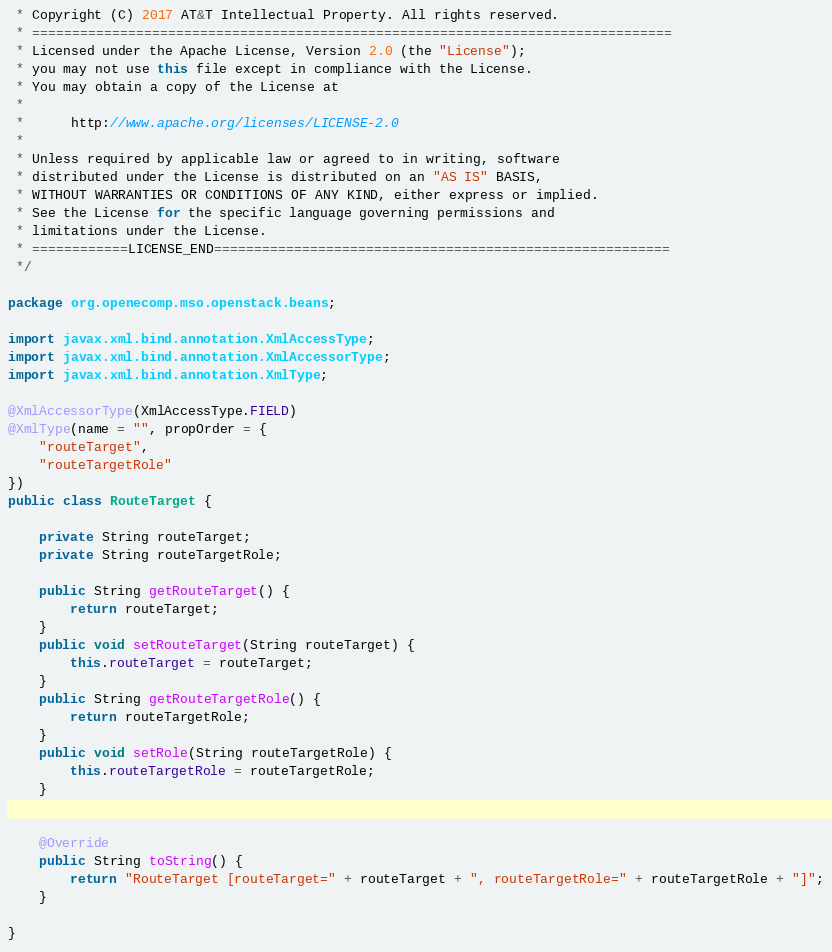Convert code to text. <code><loc_0><loc_0><loc_500><loc_500><_Java_> * Copyright (C) 2017 AT&T Intellectual Property. All rights reserved.
 * ================================================================================
 * Licensed under the Apache License, Version 2.0 (the "License");
 * you may not use this file except in compliance with the License.
 * You may obtain a copy of the License at
 * 
 *      http://www.apache.org/licenses/LICENSE-2.0
 * 
 * Unless required by applicable law or agreed to in writing, software
 * distributed under the License is distributed on an "AS IS" BASIS,
 * WITHOUT WARRANTIES OR CONDITIONS OF ANY KIND, either express or implied.
 * See the License for the specific language governing permissions and
 * limitations under the License.
 * ============LICENSE_END=========================================================
 */

package org.openecomp.mso.openstack.beans;

import javax.xml.bind.annotation.XmlAccessType;
import javax.xml.bind.annotation.XmlAccessorType;
import javax.xml.bind.annotation.XmlType;

@XmlAccessorType(XmlAccessType.FIELD)
@XmlType(name = "", propOrder = {
    "routeTarget",
    "routeTargetRole"
})
public class RouteTarget {

	private String routeTarget;
	private String routeTargetRole;
	
	public String getRouteTarget() {
		return routeTarget;
	}
	public void setRouteTarget(String routeTarget) {
		this.routeTarget = routeTarget;
	}
	public String getRouteTargetRole() {
		return routeTargetRole;
	}
	public void setRole(String routeTargetRole) {
		this.routeTargetRole = routeTargetRole;
	}
	
	
	@Override
	public String toString() {
		return "RouteTarget [routeTarget=" + routeTarget + ", routeTargetRole=" + routeTargetRole + "]";
	}
	
}
</code> 